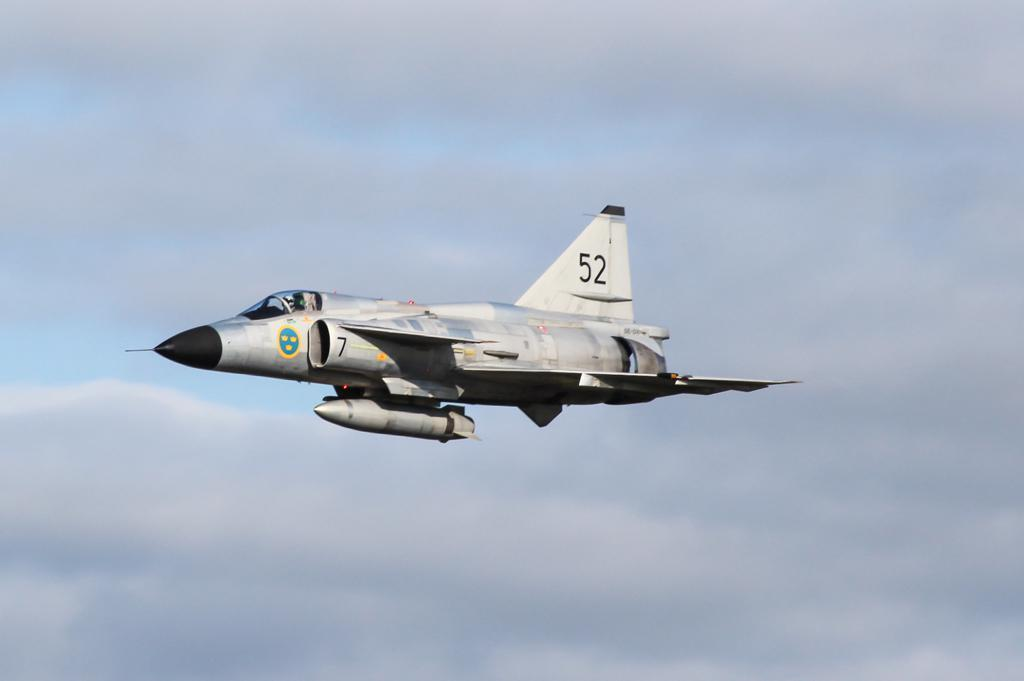<image>
Give a short and clear explanation of the subsequent image. A fighter jet is flying in the clouds with the tail number 52. 